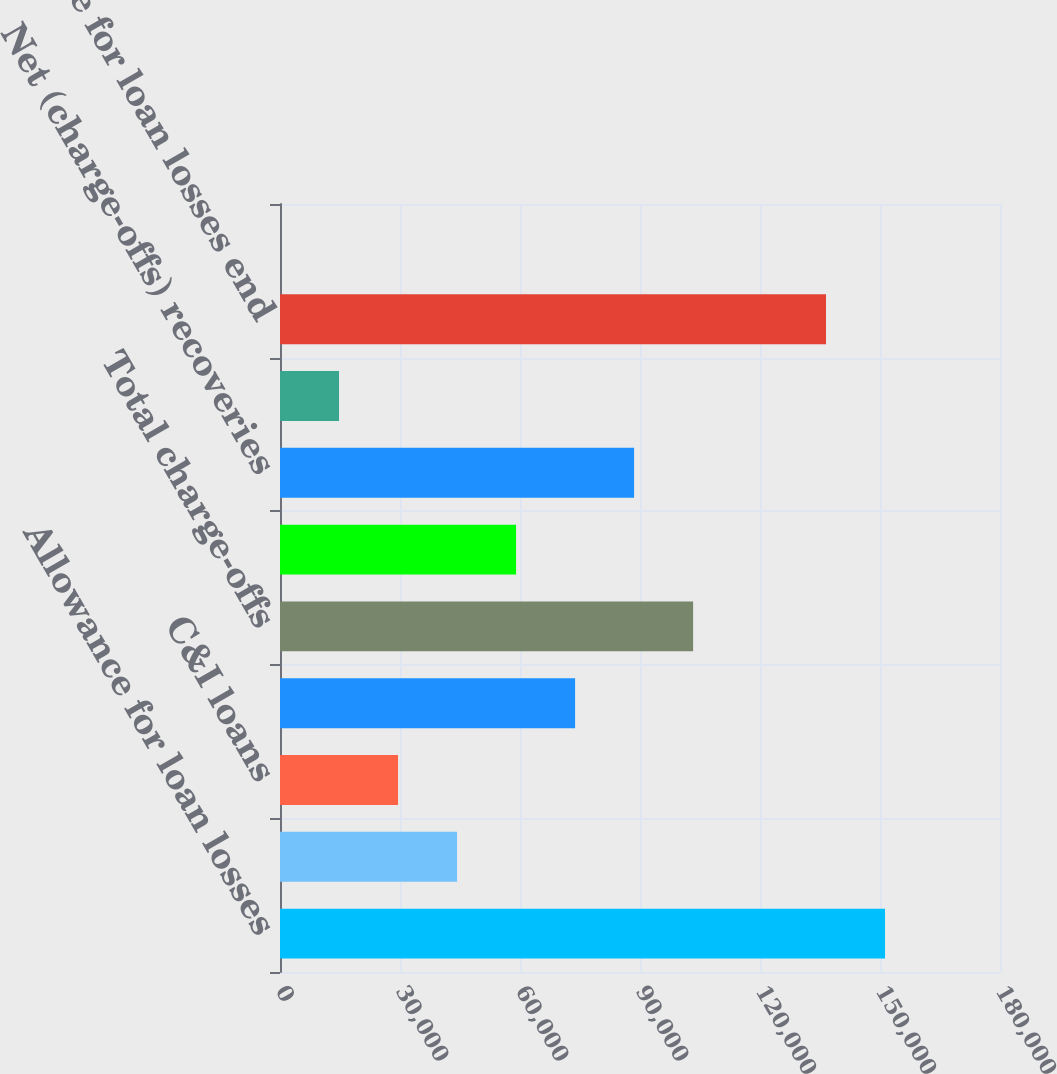<chart> <loc_0><loc_0><loc_500><loc_500><bar_chart><fcel>Allowance for loan losses<fcel>Provision for loan losses<fcel>C&I loans<fcel>Residential mortgage loans<fcel>Total charge-offs<fcel>Total recoveries<fcel>Net (charge-offs) recoveries<fcel>Foreign exchange translation<fcel>Allowance for loan losses end<fcel>Allowance for loan losses to<nl><fcel>151255<fcel>44263.4<fcel>29509.4<fcel>73771.3<fcel>103279<fcel>59017.3<fcel>88525.2<fcel>14755.5<fcel>136501<fcel>1.52<nl></chart> 